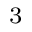Convert formula to latex. <formula><loc_0><loc_0><loc_500><loc_500>^ { 3 }</formula> 